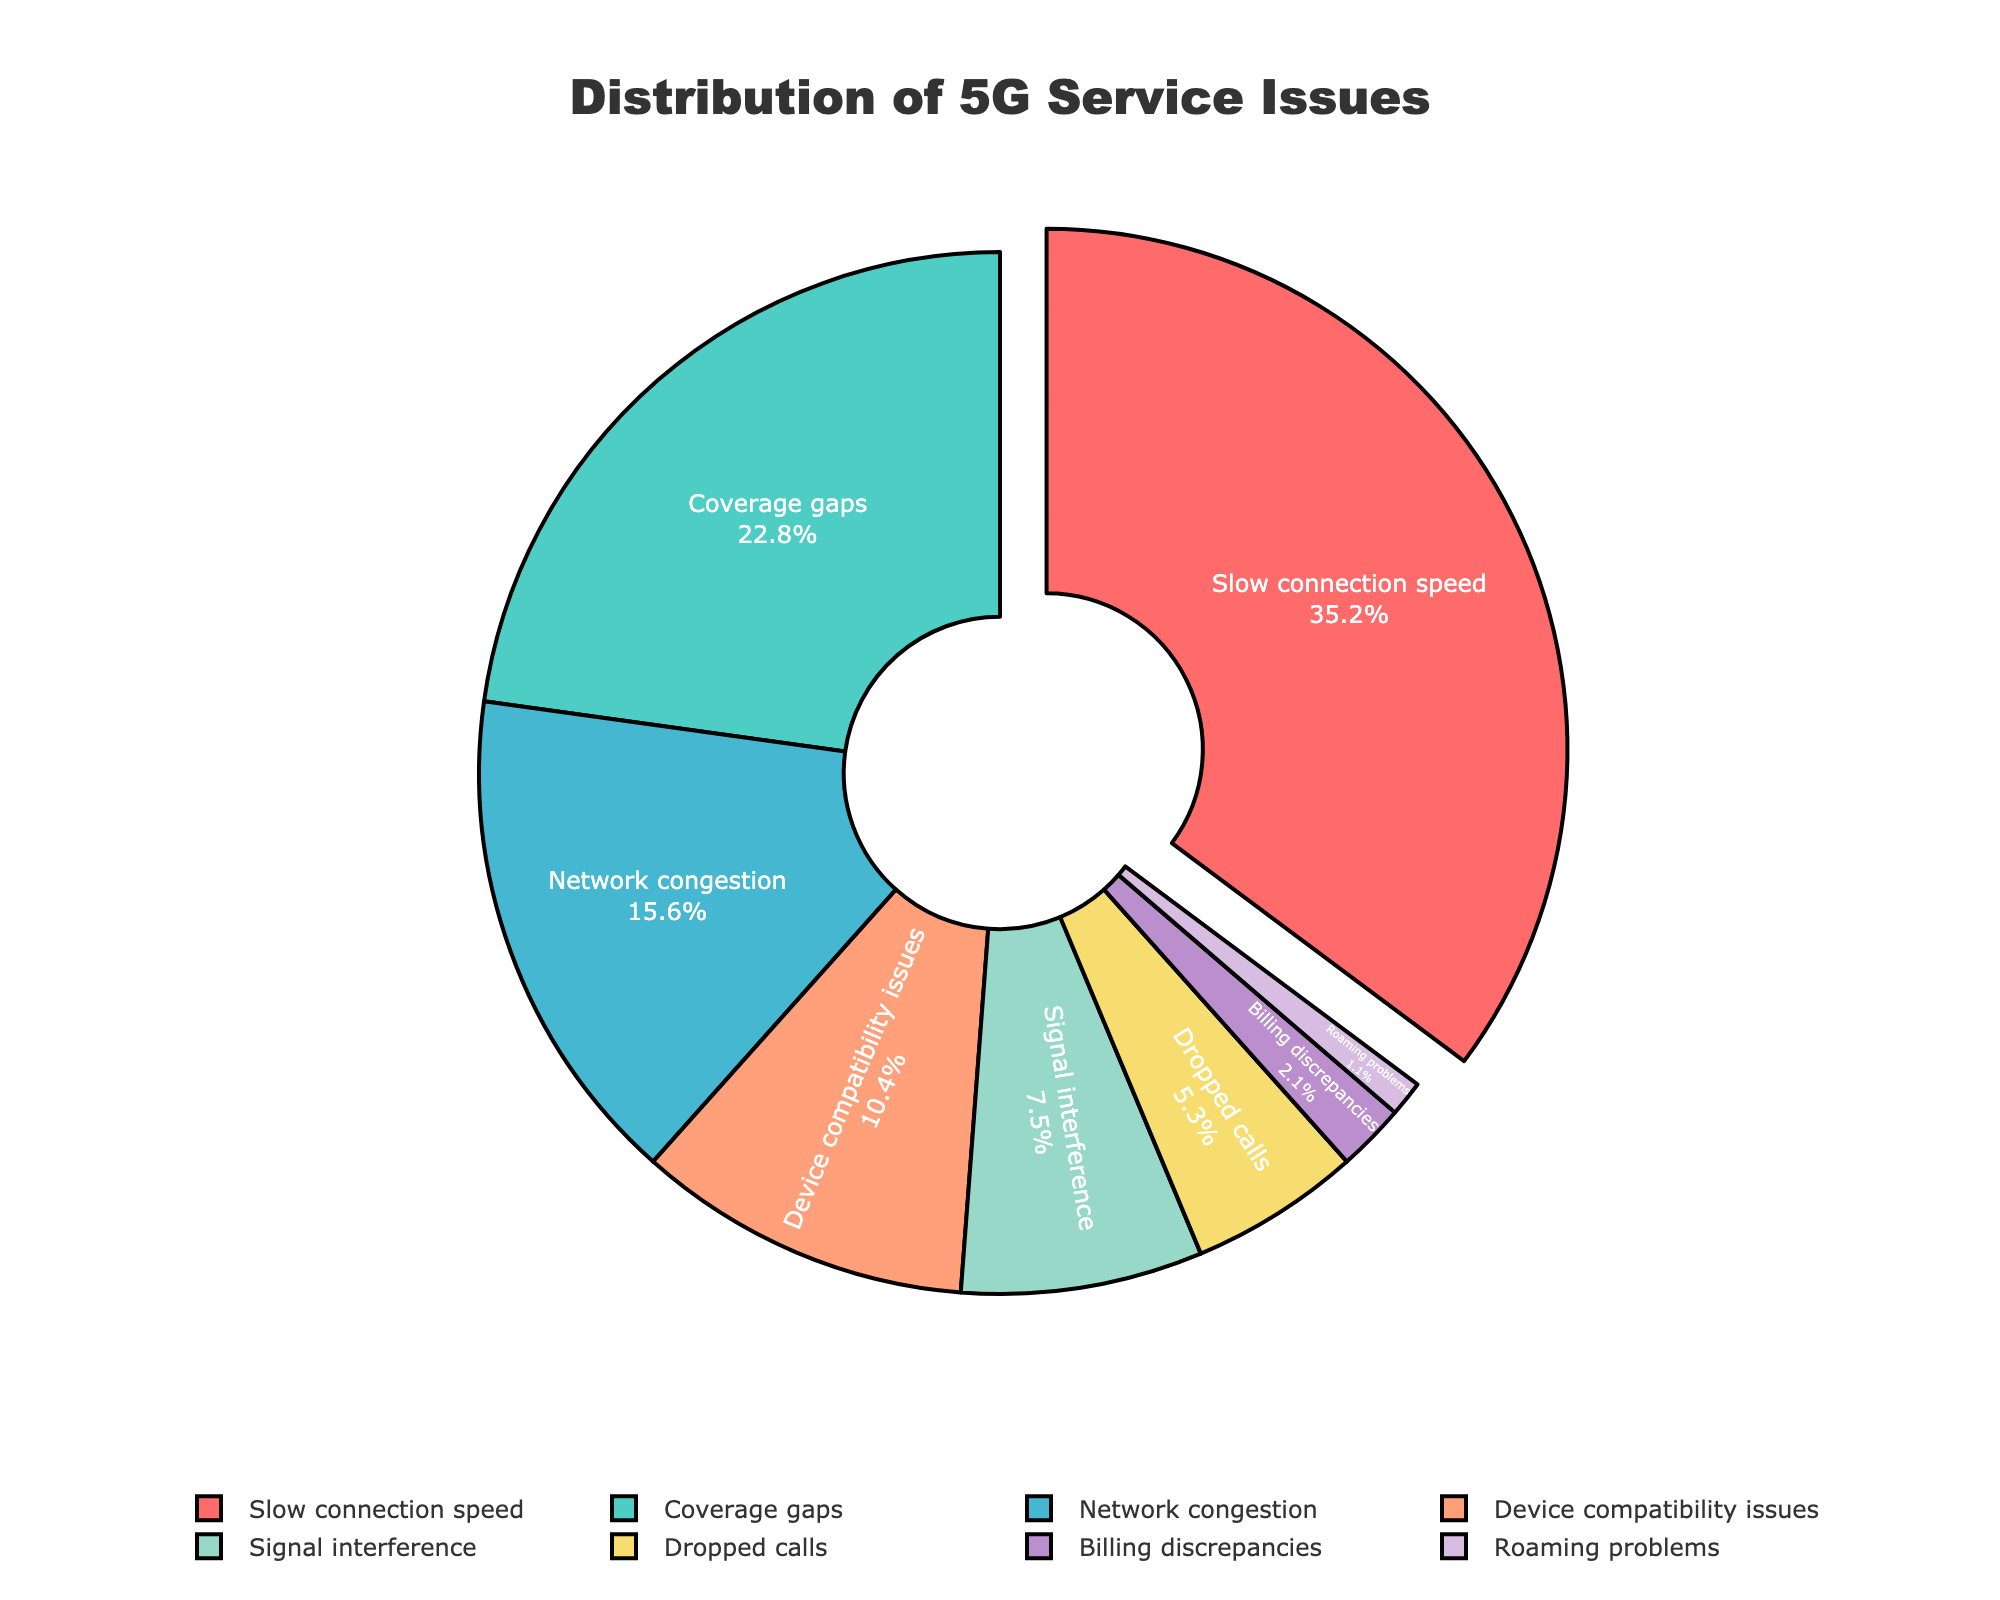What percentage of customer complaints relate to coverage gaps? Look at the section labeled "Coverage gaps" in the pie chart and note the percentage.
Answer: 22.8% What category has the highest percentage of complaints, and what is it? Identify the largest section in the pie chart. The section pulled out slightly indicates it has the highest percentage.
Answer: Slow connection speed, 35.2% How do the percentages of coverage gaps and network congestion complaints compare? Compare the sections labeled "Coverage gaps" and "Network congestion" in the pie chart. Note their percentages. Coverage gaps are 22.8%, which is higher than network congestion at 15.6%.
Answer: Coverage gaps > Network congestion What is the total percentage of complaints that relate to dropped calls, billing discrepancies, and roaming problems? Add the percentages of the sections labeled "Dropped calls" (5.3%), "Billing discrepancies" (2.1%), and "Roaming problems" (1.1%). 5.3 + 2.1 + 1.1 = 8.5
Answer: 8.5% Which category has a lower percentage of complaints: signal interference or device compatibility issues? Look at the sections labeled "Signal interference" and "Device compatibility issues". Signal interference is 7.5%, and device compatibility issues are 10.4%. Signal interference is lower.
Answer: Signal interference What fraction of the total complaints is attributed to slow connection speed? Slow connection speed has a percentage of 35.2%. To convert this percentage to a fraction: 35.2/100 = 0.352, which simplifies to 352/1000 or 176/500.
Answer: 176/500 If we combine complaints about slow connection speed and coverage gaps, what is the combined percentage? Add the percentages for "Slow connection speed" (35.2%) and "Coverage gaps" (22.8%). 35.2 + 22.8 = 58.0
Answer: 58.0% What category is represented by the purple section of the pie chart? Identify the purple section in the pie chart and look at the corresponding label.
Answer: Billing discrepancies How much greater is the percentage of complaints about slow connection speed compared to device compatibility issues? Subtract the percentage of "Device compatibility issues" (10.4%) from "Slow connection speed" (35.2%). 35.2 - 10.4 = 24.8
Answer: 24.8% Which categories combined make up less than 10% of the total complaints? Add up the percentages of the categories from smallest to largest until you reach a sum that is less than 10%. "Billing discrepancies" (2.1%) + "Roaming problems" (1.1%) = 3.2%, which is less than 10%.
Answer: Billing discrepancies, Roaming problems 